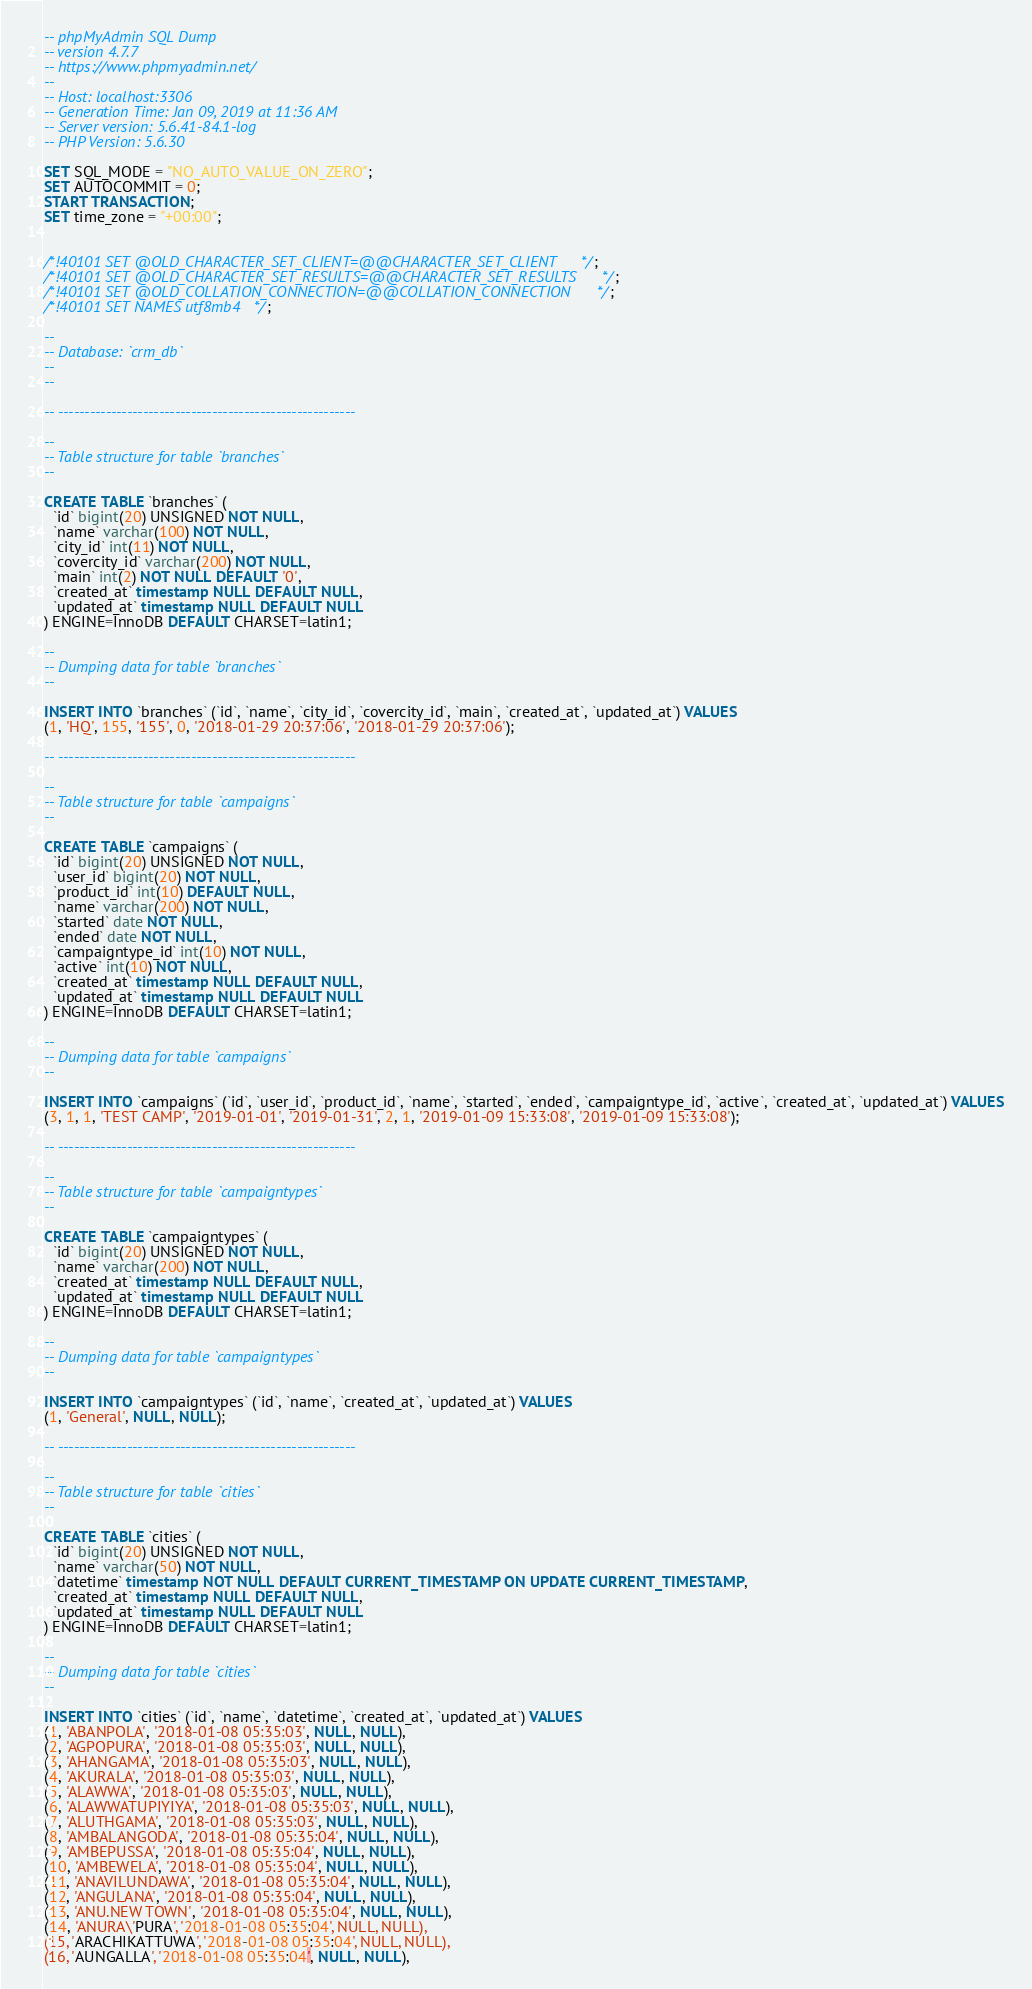<code> <loc_0><loc_0><loc_500><loc_500><_SQL_>-- phpMyAdmin SQL Dump
-- version 4.7.7
-- https://www.phpmyadmin.net/
--
-- Host: localhost:3306
-- Generation Time: Jan 09, 2019 at 11:36 AM
-- Server version: 5.6.41-84.1-log
-- PHP Version: 5.6.30

SET SQL_MODE = "NO_AUTO_VALUE_ON_ZERO";
SET AUTOCOMMIT = 0;
START TRANSACTION;
SET time_zone = "+00:00";


/*!40101 SET @OLD_CHARACTER_SET_CLIENT=@@CHARACTER_SET_CLIENT */;
/*!40101 SET @OLD_CHARACTER_SET_RESULTS=@@CHARACTER_SET_RESULTS */;
/*!40101 SET @OLD_COLLATION_CONNECTION=@@COLLATION_CONNECTION */;
/*!40101 SET NAMES utf8mb4 */;

--
-- Database: `crm_db`
--
--

-- --------------------------------------------------------

--
-- Table structure for table `branches`
--

CREATE TABLE `branches` (
  `id` bigint(20) UNSIGNED NOT NULL,
  `name` varchar(100) NOT NULL,
  `city_id` int(11) NOT NULL,
  `covercity_id` varchar(200) NOT NULL,
  `main` int(2) NOT NULL DEFAULT '0',
  `created_at` timestamp NULL DEFAULT NULL,
  `updated_at` timestamp NULL DEFAULT NULL
) ENGINE=InnoDB DEFAULT CHARSET=latin1;

--
-- Dumping data for table `branches`
--

INSERT INTO `branches` (`id`, `name`, `city_id`, `covercity_id`, `main`, `created_at`, `updated_at`) VALUES
(1, 'HQ', 155, '155', 0, '2018-01-29 20:37:06', '2018-01-29 20:37:06');

-- --------------------------------------------------------

--
-- Table structure for table `campaigns`
--

CREATE TABLE `campaigns` (
  `id` bigint(20) UNSIGNED NOT NULL,
  `user_id` bigint(20) NOT NULL,
  `product_id` int(10) DEFAULT NULL,
  `name` varchar(200) NOT NULL,
  `started` date NOT NULL,
  `ended` date NOT NULL,
  `campaigntype_id` int(10) NOT NULL,
  `active` int(10) NOT NULL,
  `created_at` timestamp NULL DEFAULT NULL,
  `updated_at` timestamp NULL DEFAULT NULL
) ENGINE=InnoDB DEFAULT CHARSET=latin1;

--
-- Dumping data for table `campaigns`
--

INSERT INTO `campaigns` (`id`, `user_id`, `product_id`, `name`, `started`, `ended`, `campaigntype_id`, `active`, `created_at`, `updated_at`) VALUES
(3, 1, 1, 'TEST CAMP', '2019-01-01', '2019-01-31', 2, 1, '2019-01-09 15:33:08', '2019-01-09 15:33:08');

-- --------------------------------------------------------

--
-- Table structure for table `campaigntypes`
--

CREATE TABLE `campaigntypes` (
  `id` bigint(20) UNSIGNED NOT NULL,
  `name` varchar(200) NOT NULL,
  `created_at` timestamp NULL DEFAULT NULL,
  `updated_at` timestamp NULL DEFAULT NULL
) ENGINE=InnoDB DEFAULT CHARSET=latin1;

--
-- Dumping data for table `campaigntypes`
--

INSERT INTO `campaigntypes` (`id`, `name`, `created_at`, `updated_at`) VALUES
(1, 'General', NULL, NULL);

-- --------------------------------------------------------

--
-- Table structure for table `cities`
--

CREATE TABLE `cities` (
  `id` bigint(20) UNSIGNED NOT NULL,
  `name` varchar(50) NOT NULL,
  `datetime` timestamp NOT NULL DEFAULT CURRENT_TIMESTAMP ON UPDATE CURRENT_TIMESTAMP,
  `created_at` timestamp NULL DEFAULT NULL,
  `updated_at` timestamp NULL DEFAULT NULL
) ENGINE=InnoDB DEFAULT CHARSET=latin1;

--
-- Dumping data for table `cities`
--

INSERT INTO `cities` (`id`, `name`, `datetime`, `created_at`, `updated_at`) VALUES
(1, 'ABANPOLA', '2018-01-08 05:35:03', NULL, NULL),
(2, 'AGPOPURA', '2018-01-08 05:35:03', NULL, NULL),
(3, 'AHANGAMA', '2018-01-08 05:35:03', NULL, NULL),
(4, 'AKURALA', '2018-01-08 05:35:03', NULL, NULL),
(5, 'ALAWWA', '2018-01-08 05:35:03', NULL, NULL),
(6, 'ALAWWATUPIYIYA', '2018-01-08 05:35:03', NULL, NULL),
(7, 'ALUTHGAMA', '2018-01-08 05:35:03', NULL, NULL),
(8, 'AMBALANGODA', '2018-01-08 05:35:04', NULL, NULL),
(9, 'AMBEPUSSA', '2018-01-08 05:35:04', NULL, NULL),
(10, 'AMBEWELA', '2018-01-08 05:35:04', NULL, NULL),
(11, 'ANAVILUNDAWA', '2018-01-08 05:35:04', NULL, NULL),
(12, 'ANGULANA', '2018-01-08 05:35:04', NULL, NULL),
(13, 'ANU.NEW TOWN', '2018-01-08 05:35:04', NULL, NULL),
(14, 'ANURA\'PURA', '2018-01-08 05:35:04', NULL, NULL),
(15, 'ARACHIKATTUWA', '2018-01-08 05:35:04', NULL, NULL),
(16, 'AUNGALLA', '2018-01-08 05:35:04', NULL, NULL),</code> 